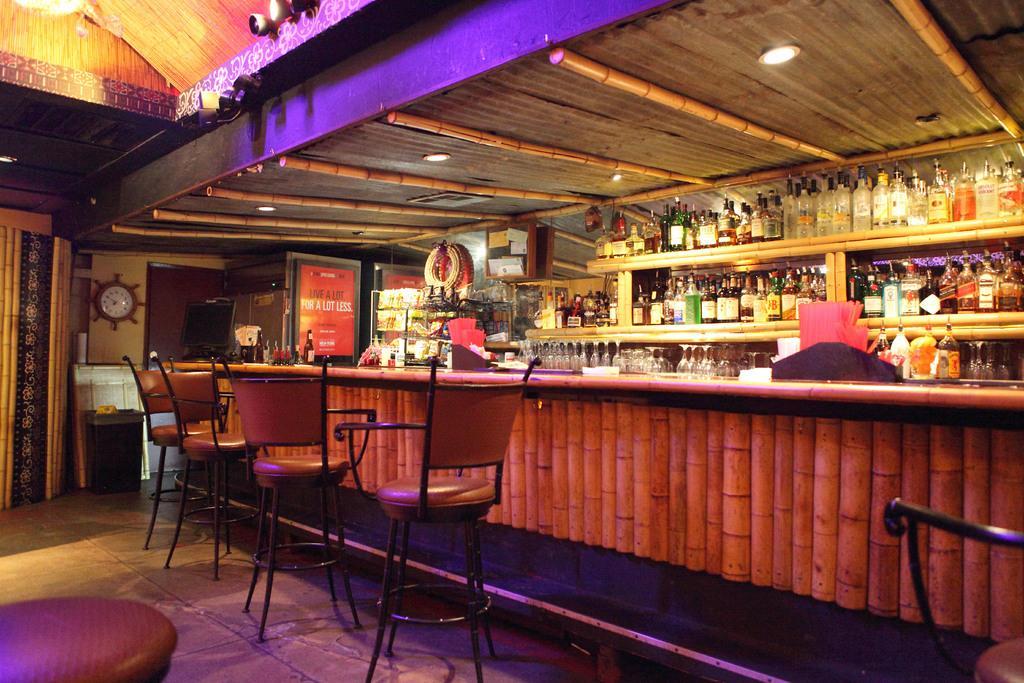Please provide a concise description of this image. In this image we can see there is an inside view of the building. And there are chairs on the floor. There is a clock attached to the wall. And there is a table, on the table there are boards. At the back there are racks, in that there are bottles, glasses and at the side it looks like a refrigerator. At the top there is a ceiling with lights and cameras attached to the board. 